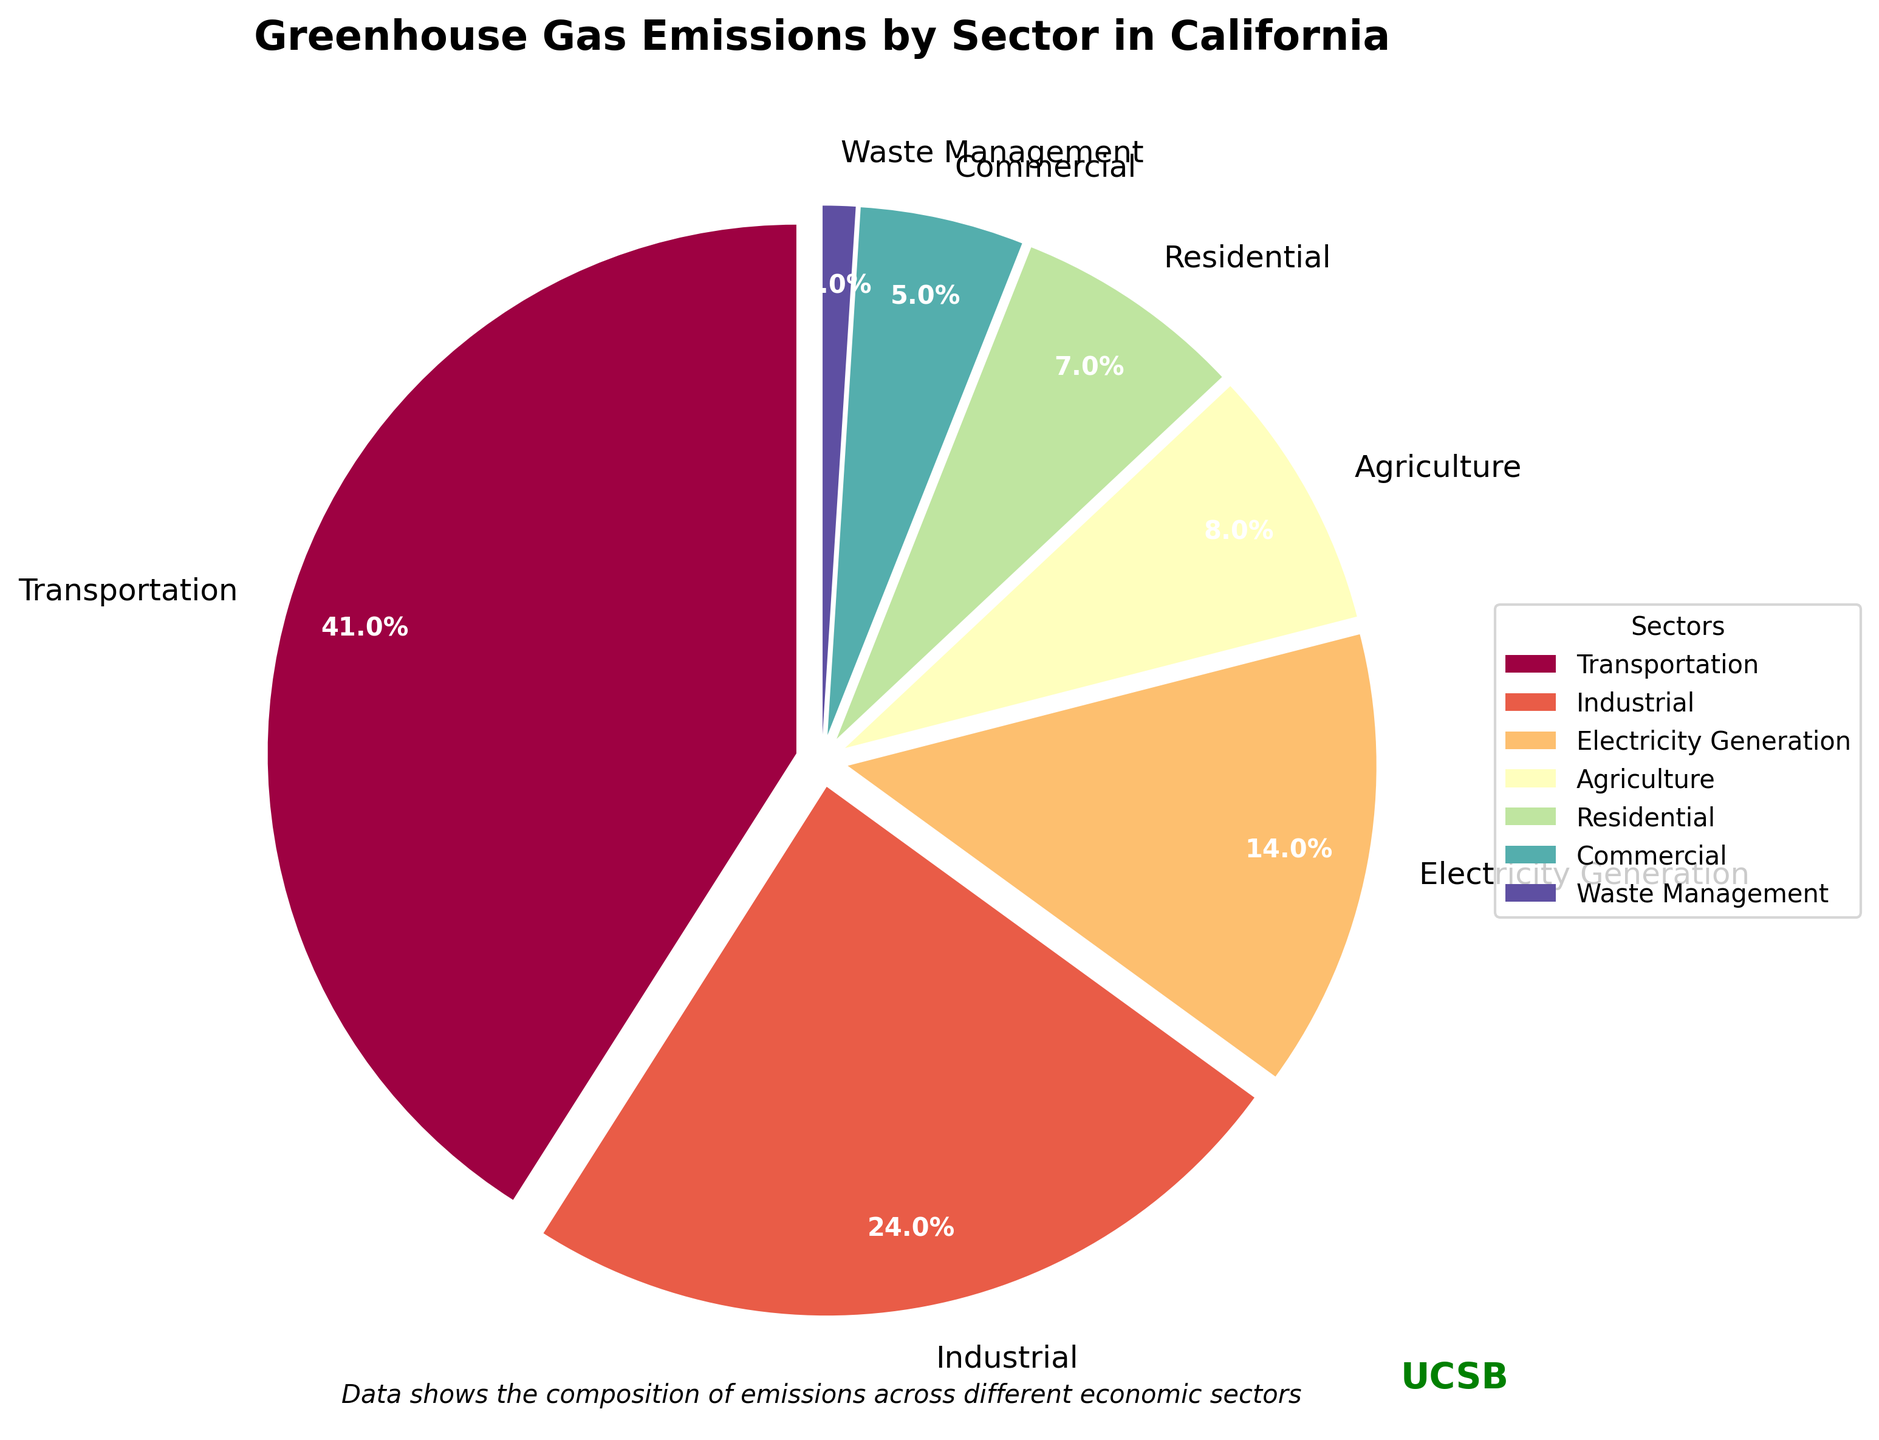What's the sector with the highest percentage of greenhouse gas emissions? The largest wedge in the pie chart should represent the sector with the highest percentage. By observing the visual sizes and labels, it's evident that the Transportation sector is the largest.
Answer: Transportation How much more percentage does the Transportation sector contribute compared to the Industrial sector? From the chart, the Transportation sector is 41% and the Industrial sector is 24%. The difference between them is calculated as 41% - 24%.
Answer: 17% What are the combined greenhouse gas emissions percentages of the Residential and Commercial sectors? From the chart, the Residential sector is 7% and the Commercial sector is 5%. Adding these together gives 7% + 5%.
Answer: 12% Which sector contributes the least to greenhouse gas emissions, and what is its percentage share? By observing the pie chart, the smallest wedge represents the sector with the lowest percentage. The Waste Management sector is the smallest, labeled as 1%.
Answer: Waste Management, 1% Does the Agriculture sector contribute more or less than the combination of Residential and Commercial sectors? The Agriculture sector contributes 8%, while the combined contribution of Residential (7%) and Commercial (5%) sectors is 12%. 8% is less than 12%.
Answer: Less Which wedge is colored differently than the others and represents a sector with a 5% contribution? The pie chart uses distinct colors for each sector. The Commercial sector, which contributes 5%, should be identified by its unique color and percentage label.
Answer: Commercial What is the difference in greenhouse gas emissions percentages between the Electricity Generation and Agriculture sectors? From the pie chart, Electricity Generation is 14%, and Agriculture is 8%. The difference between them is 14% - 8%.
Answer: 6% Arrange the sectors in descending order of their greenhouse gas emissions contributions. By inspecting the size of wedges and their labels, the order from highest to lowest is: Transportation (41%), Industrial (24%), Electricity Generation (14%), Agriculture (8%), Residential (7%), Commercial (5%), Waste Management (1%).
Answer: Transportation, Industrial, Electricity Generation, Agriculture, Residential, Commercial, Waste Management What's the total percentage of greenhouse gas emissions contributed by sectors other than Transportation? Summing the percentages of all sectors except Transportation (41%): Industrial (24%) + Electricity Generation (14%) + Agriculture (8%) + Residential (7%) + Commercial (5%) + Waste Management (1%) which totals to 59%.
Answer: 59% How does the percentage contribution of the Industrial sector compare to the total contribution of Residential, Commercial, and Waste Management sectors? The Industrial sector contributes 24%. The combined contributions of Residential (7%), Commercial (5%), and Waste Management (1%) is 7% + 5% + 1% = 13%. 24% is greater than 13%.
Answer: Greater 